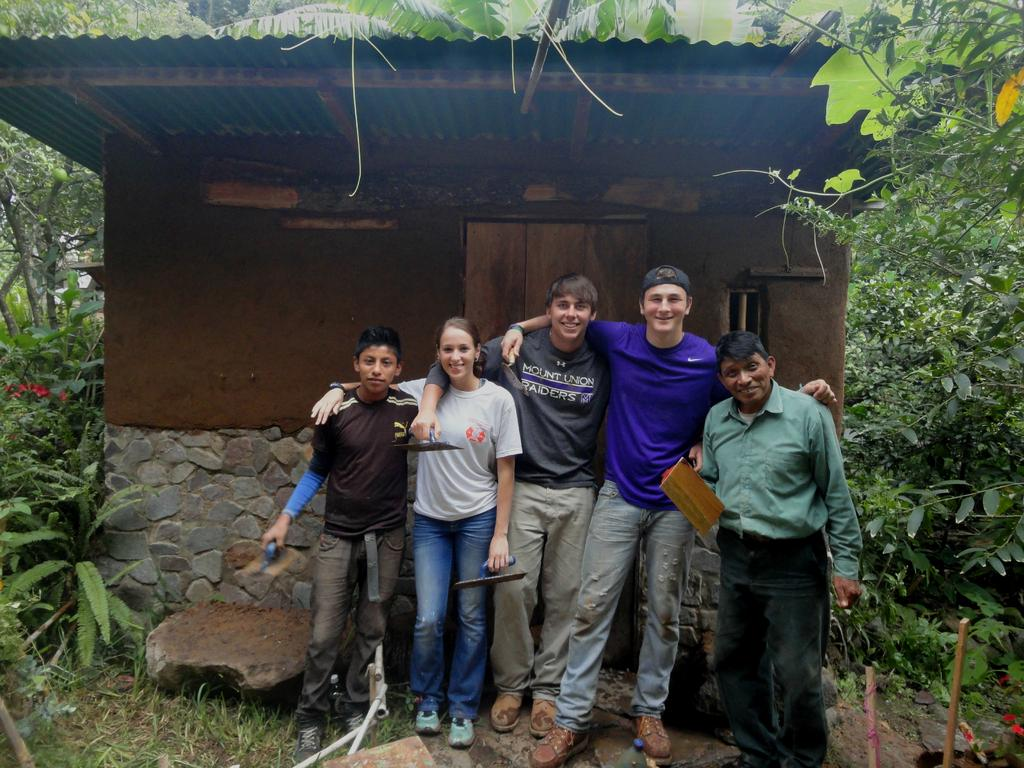Who or what can be seen in the image? There are people in the image. What type of natural elements are present in the image? There are plants, trees, and grass in the image. What type of structure is visible in the image? There is a house in the image. What architectural features can be seen in the image? There is a wall in the image. What additional object is present in the image? There is a stone in the image. Where is the suit located in the image? There is no suit present in the image. What type of bird's nest can be seen in the image? There is no bird's nest present in the image. 